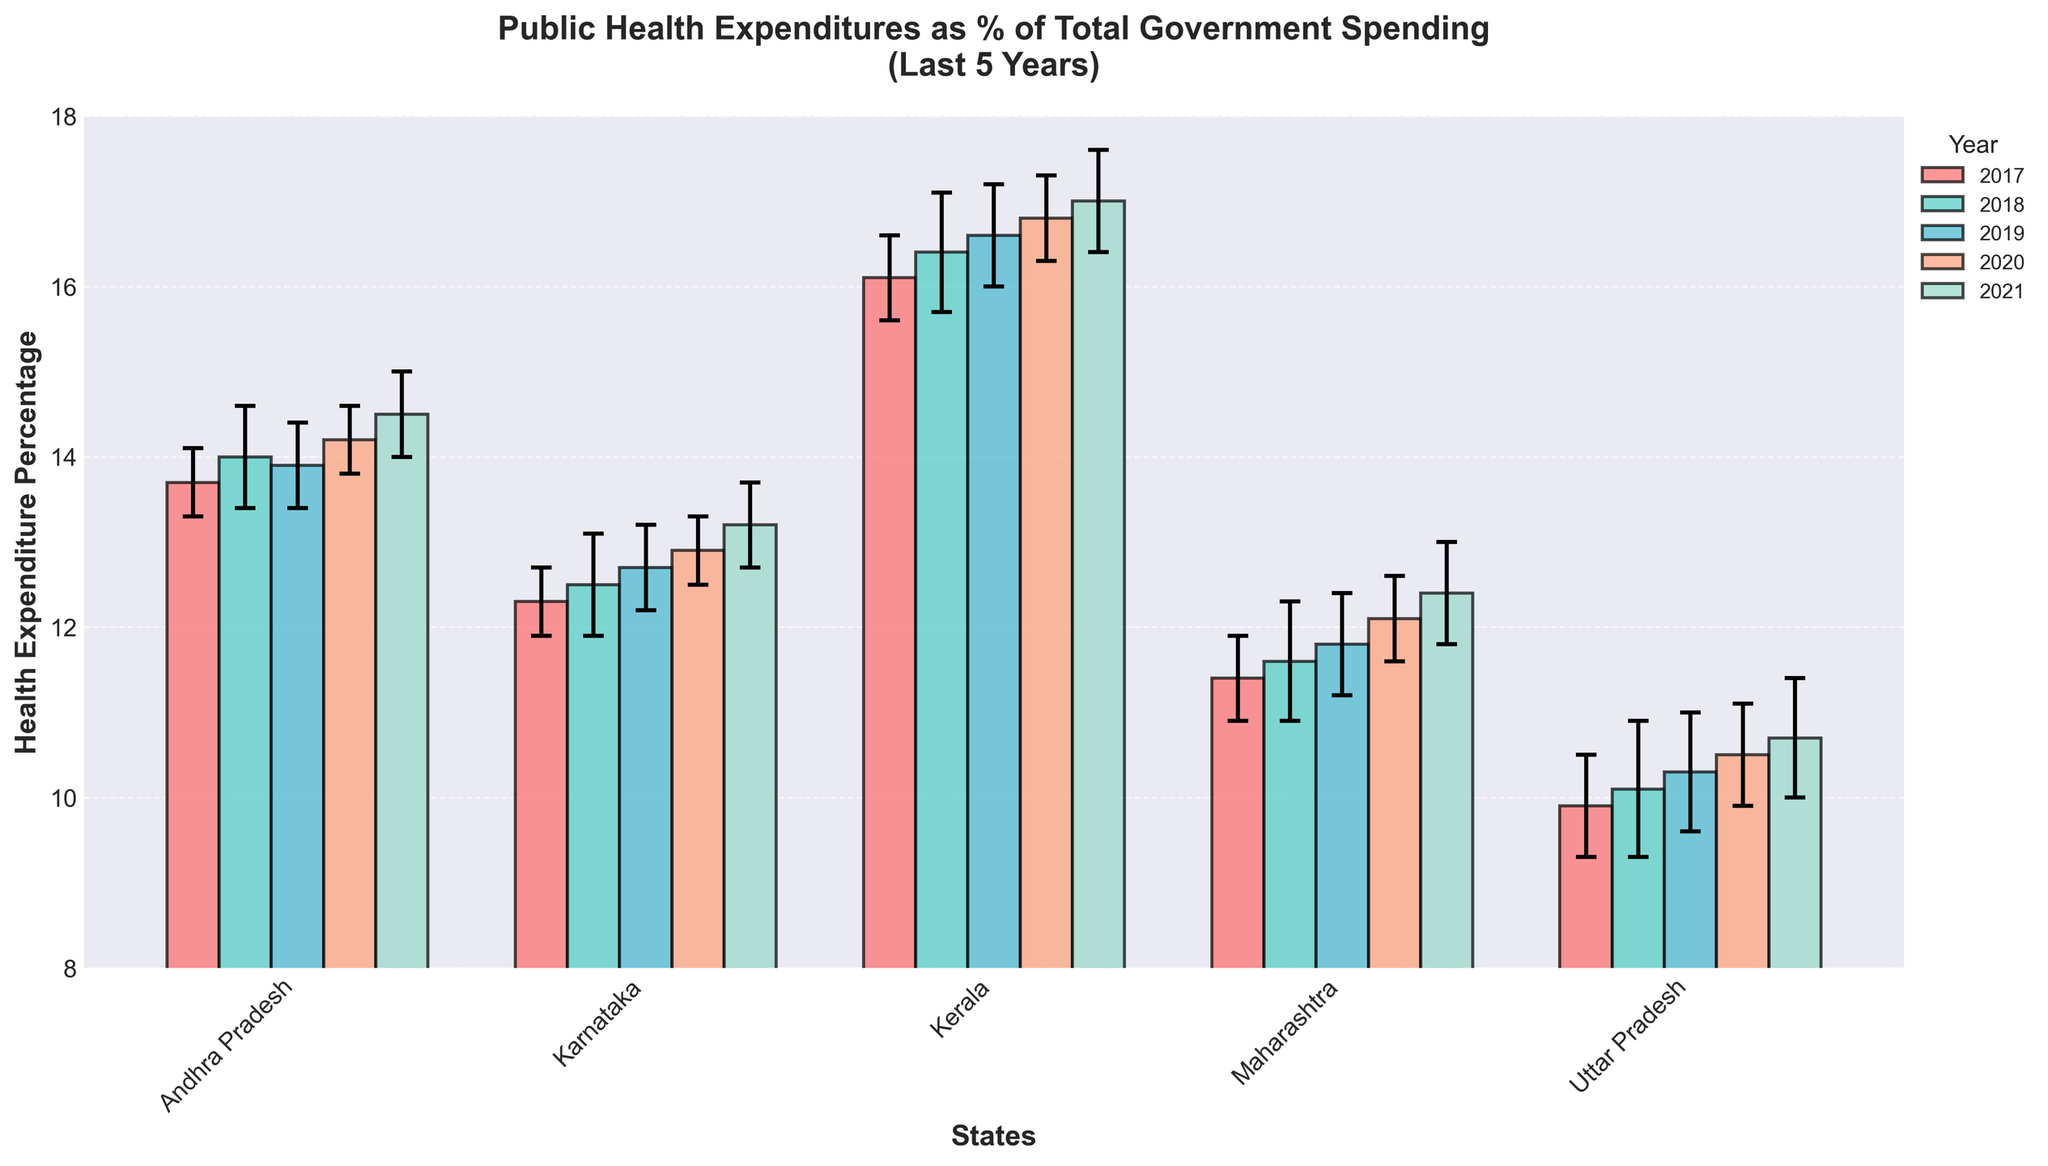What is the title of the figure? The title of the figure is centered at the top of the chart, and it reads "Public Health Expenditures as % of Total Government Spending (Last 5 Years)".
Answer: Public Health Expenditures as % of Total Government Spending (Last 5 Years) Which state had the highest health expenditure percentage in 2021? By looking at the bars for the year 2021, we can see that Kerala has the highest bar, indicating the highest health expenditure percentage among the states listed.
Answer: Kerala How much did Andhra Pradesh's health expenditure percentage change from 2017 to 2021? For Andhra Pradesh in 2017, the health expenditure was 13.7%, and in 2021, it was 14.5%. Subtracting these, 14.5% - 13.7%, gives an increase of 0.8%.
Answer: 0.8% Which state showed the smallest standard error in health expenditure percentage in the most recent year? Observing the error bars for the year 2021, we see that Kerala has the smallest range of error bars, indicating the smallest standard error.
Answer: Kerala Between Karnataka and Maharashtra, which state had a larger increase in health expenditure percentage from 2018 to 2021? For Karnataka: 2021 (13.2%) - 2018 (12.5%) = 0.7% For Maharashtra: 2021 (12.4%) - 2018 (11.6%) = 0.8% Maharashtra had a larger increase (0.8% compared to Karnataka's 0.7%).
Answer: Maharashtra From 2017 to 2021, which state experienced the greatest increase in health expenditure percentage? Comparing the increase over this period: Andhra Pradesh: 14.5% - 13.7% = 0.8% Karnataka: 13.2% - 12.3% = 0.9% Kerala: 17.0% - 16.1% = 0.9% Maharashtra: 12.4% - 11.4% = 1.0% Uttar Pradesh: 10.7% - 9.9% = 0.8% Maharashtra has the greatest increase of 1.0%.
Answer: Maharashtra Which year's data is represented by the orange bars in the chart? Referring to the color legend, the year represented by the orange bars is marked and can be seen as the year 2018.
Answer: 2018 